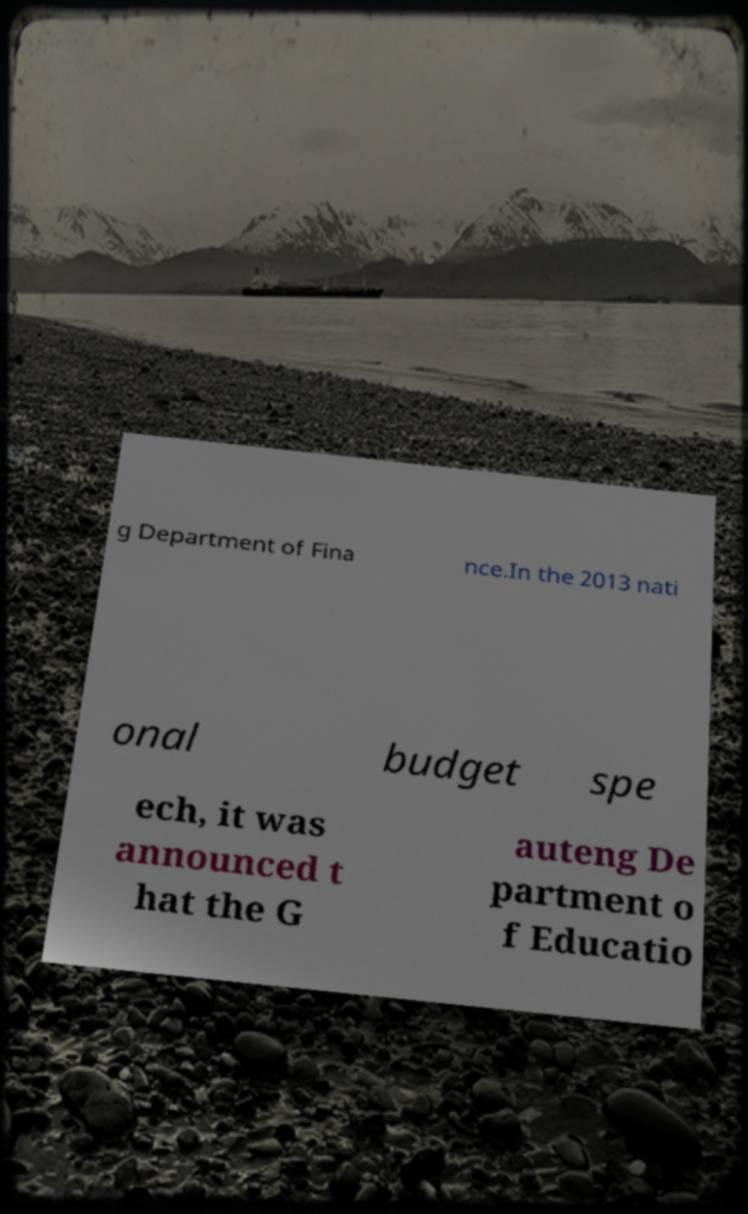There's text embedded in this image that I need extracted. Can you transcribe it verbatim? g Department of Fina nce.In the 2013 nati onal budget spe ech, it was announced t hat the G auteng De partment o f Educatio 